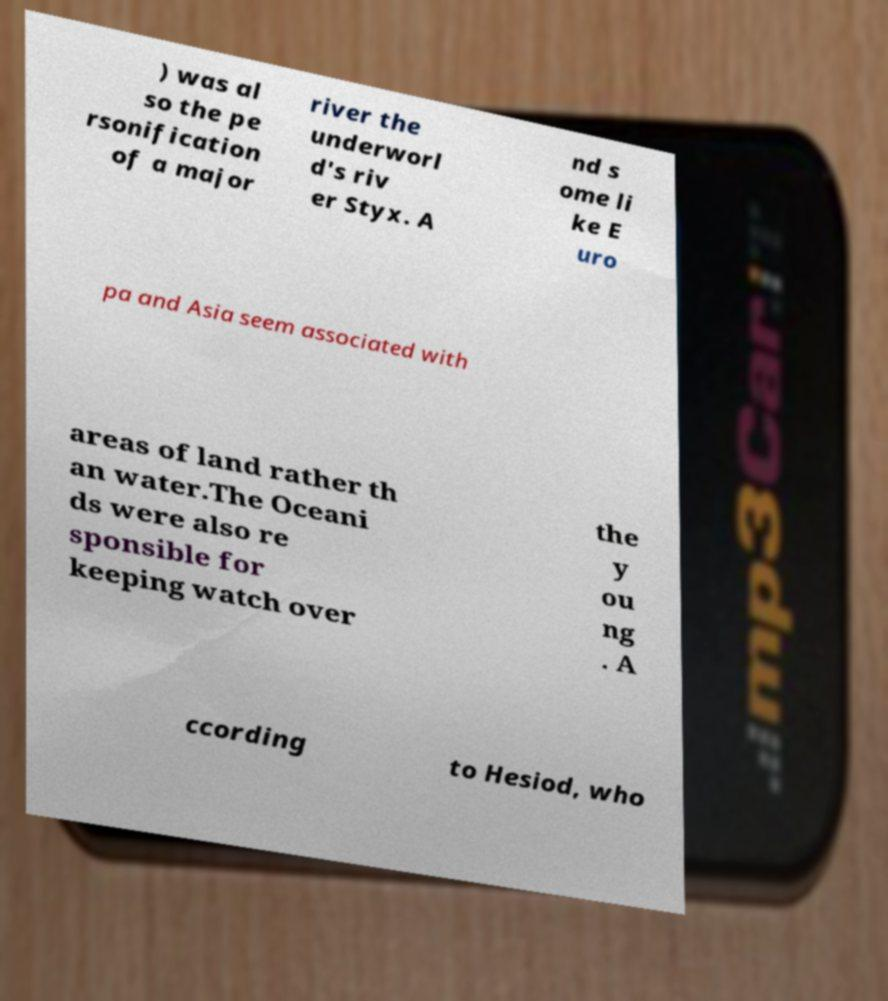For documentation purposes, I need the text within this image transcribed. Could you provide that? ) was al so the pe rsonification of a major river the underworl d's riv er Styx. A nd s ome li ke E uro pa and Asia seem associated with areas of land rather th an water.The Oceani ds were also re sponsible for keeping watch over the y ou ng . A ccording to Hesiod, who 